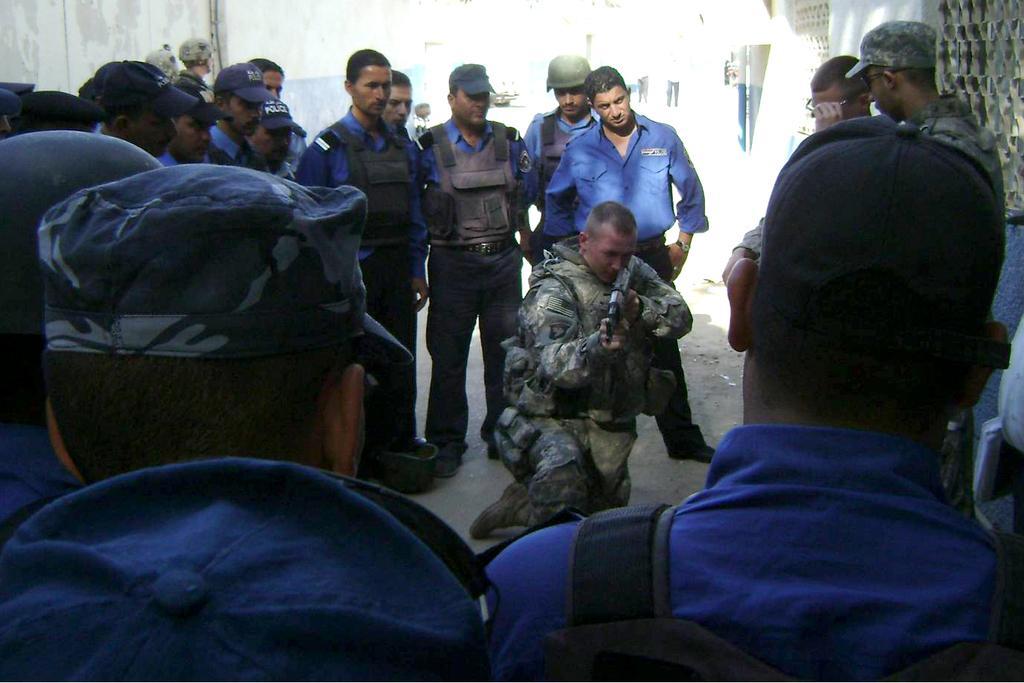In one or two sentences, can you explain what this image depicts? In this image I can see number of people and I can see all of them are wearing uniforms. I can see most of them are wearing caps and few are wearing helmets. Here I can see he is holding a gun. 